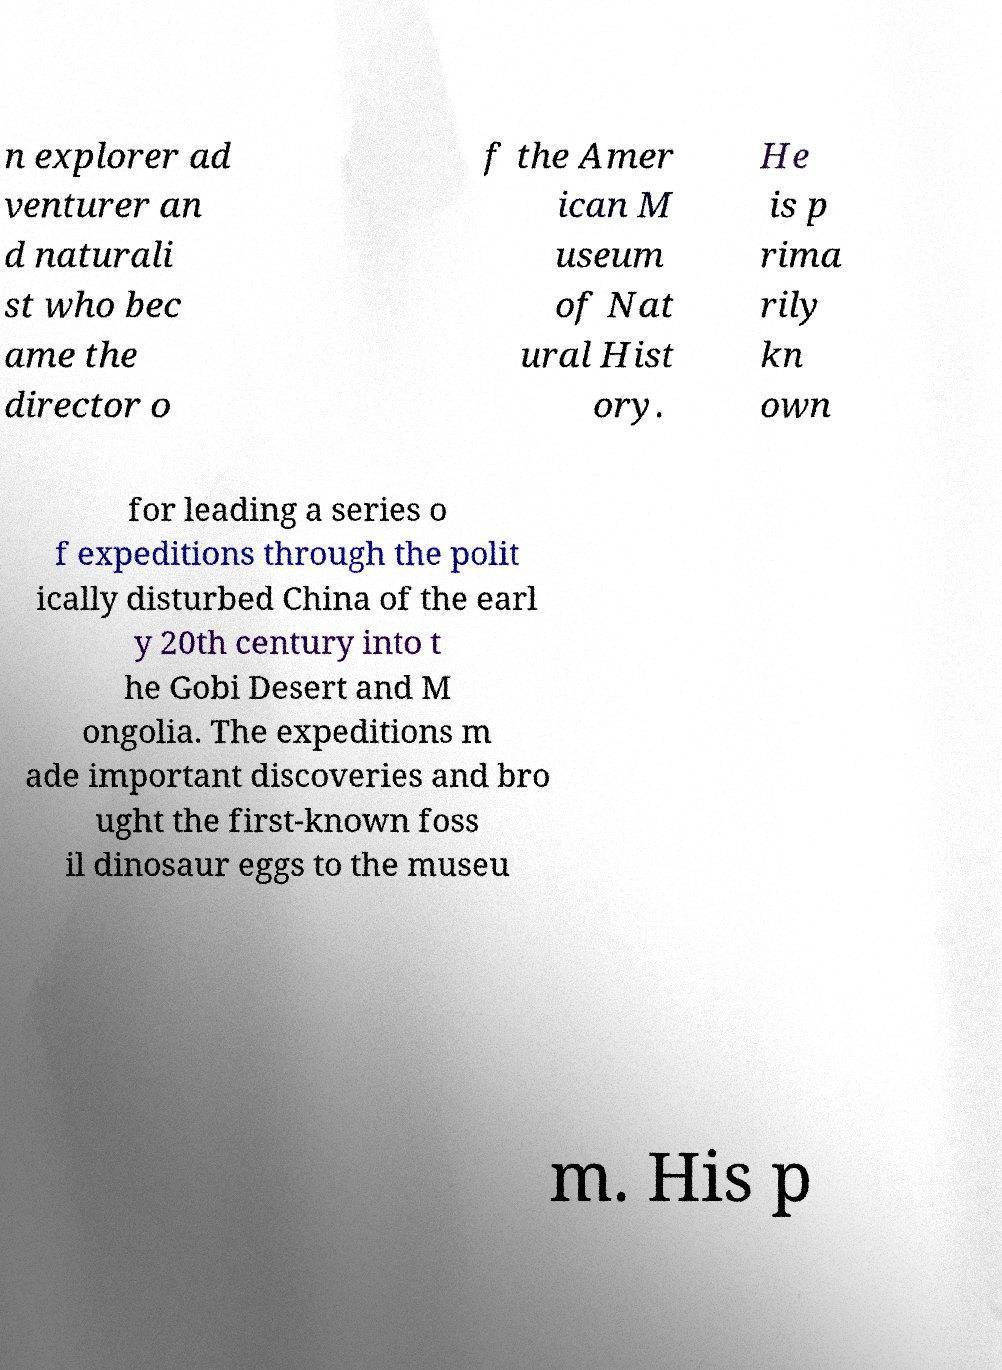For documentation purposes, I need the text within this image transcribed. Could you provide that? n explorer ad venturer an d naturali st who bec ame the director o f the Amer ican M useum of Nat ural Hist ory. He is p rima rily kn own for leading a series o f expeditions through the polit ically disturbed China of the earl y 20th century into t he Gobi Desert and M ongolia. The expeditions m ade important discoveries and bro ught the first-known foss il dinosaur eggs to the museu m. His p 